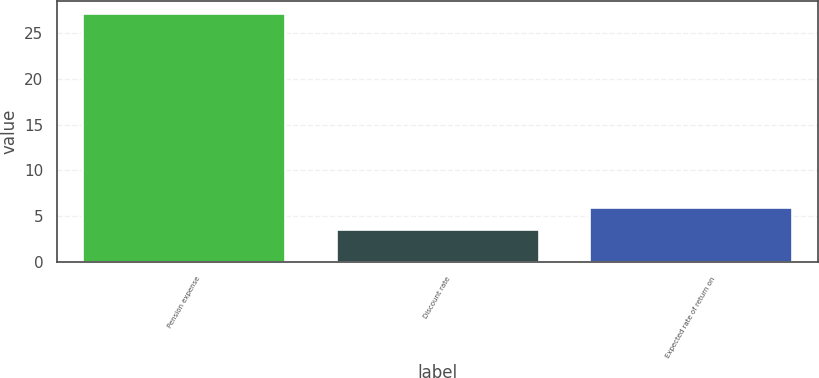Convert chart. <chart><loc_0><loc_0><loc_500><loc_500><bar_chart><fcel>Pension expense<fcel>Discount rate<fcel>Expected rate of return on<nl><fcel>27.1<fcel>3.66<fcel>6.06<nl></chart> 